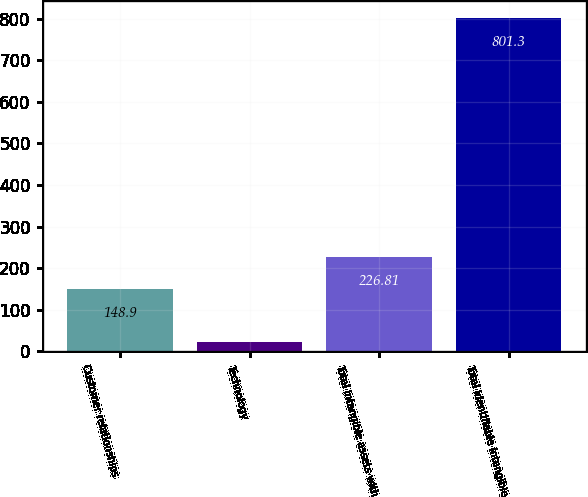<chart> <loc_0><loc_0><loc_500><loc_500><bar_chart><fcel>Customer relationships<fcel>Technology<fcel>Total intangible assets with<fcel>Total identifiable intangible<nl><fcel>148.9<fcel>22.2<fcel>226.81<fcel>801.3<nl></chart> 